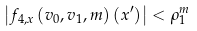Convert formula to latex. <formula><loc_0><loc_0><loc_500><loc_500>\left | f _ { 4 , x } \left ( v _ { 0 } , v _ { 1 } , { m } \right ) ( x ^ { \prime } ) \right | < \rho _ { 1 } ^ { m }</formula> 